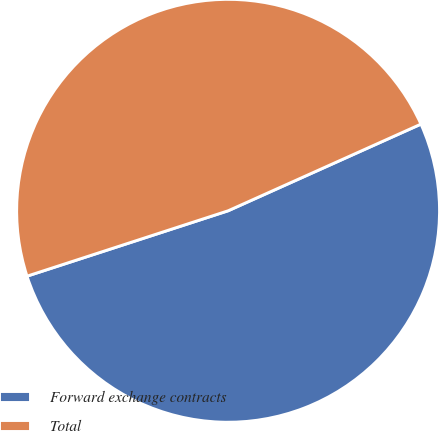<chart> <loc_0><loc_0><loc_500><loc_500><pie_chart><fcel>Forward exchange contracts<fcel>Total<nl><fcel>51.72%<fcel>48.28%<nl></chart> 